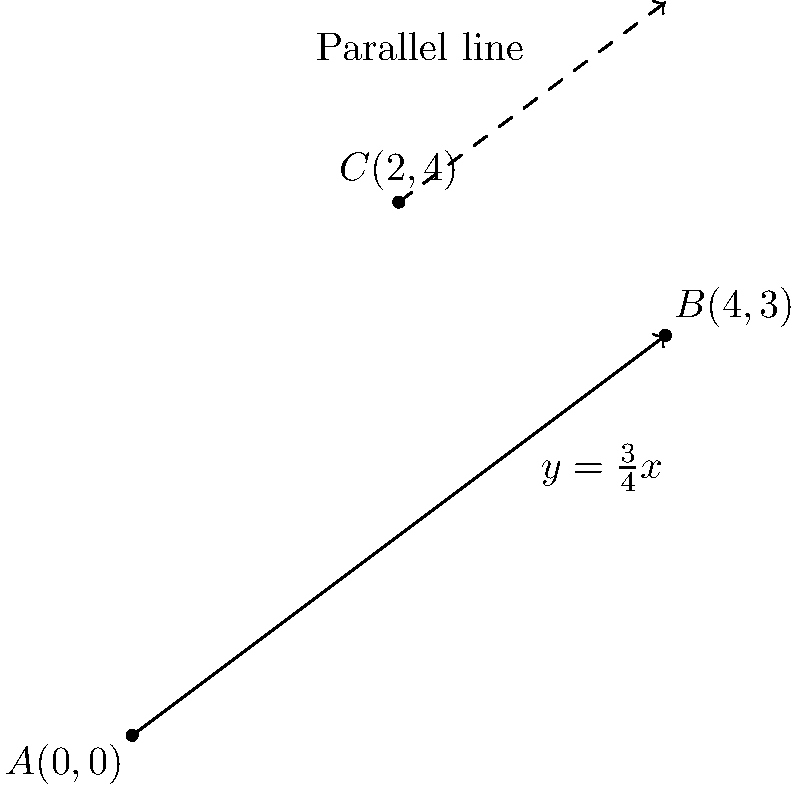As a concerned guardian encouraging safe exploration of technology, you want to teach your tech-enthusiast ward about the importance of understanding mathematical concepts in computer graphics. Consider the line passing through points $A(0,0)$ and $B(4,3)$. Find the equation of a line parallel to this line and passing through point $C(2,4)$. Let's approach this step-by-step:

1) First, we need to find the slope of the line passing through $A$ and $B$. The slope formula is:

   $$m = \frac{y_2 - y_1}{x_2 - x_1} = \frac{3 - 0}{4 - 0} = \frac{3}{4}$$

2) The equation of the line passing through $A$ and $B$ is $y = \frac{3}{4}x$.

3) Since parallel lines have the same slope, the line we're looking for will also have a slope of $\frac{3}{4}$.

4) We can use the point-slope form of a line equation: $y - y_1 = m(x - x_1)$
   Where $(x_1, y_1)$ is a point on the line (in this case, $C(2,4)$), and $m$ is the slope.

5) Substituting our values:

   $$y - 4 = \frac{3}{4}(x - 2)$$

6) Simplify by distributing $\frac{3}{4}$:

   $$y - 4 = \frac{3}{4}x - \frac{3}{2}$$

7) Add 4 to both sides:

   $$y = \frac{3}{4}x - \frac{3}{2} + 4$$

8) Simplify:

   $$y = \frac{3}{4}x + \frac{5}{2}$$

This is the equation of the line parallel to $AB$ and passing through $C$.
Answer: $y = \frac{3}{4}x + \frac{5}{2}$ 